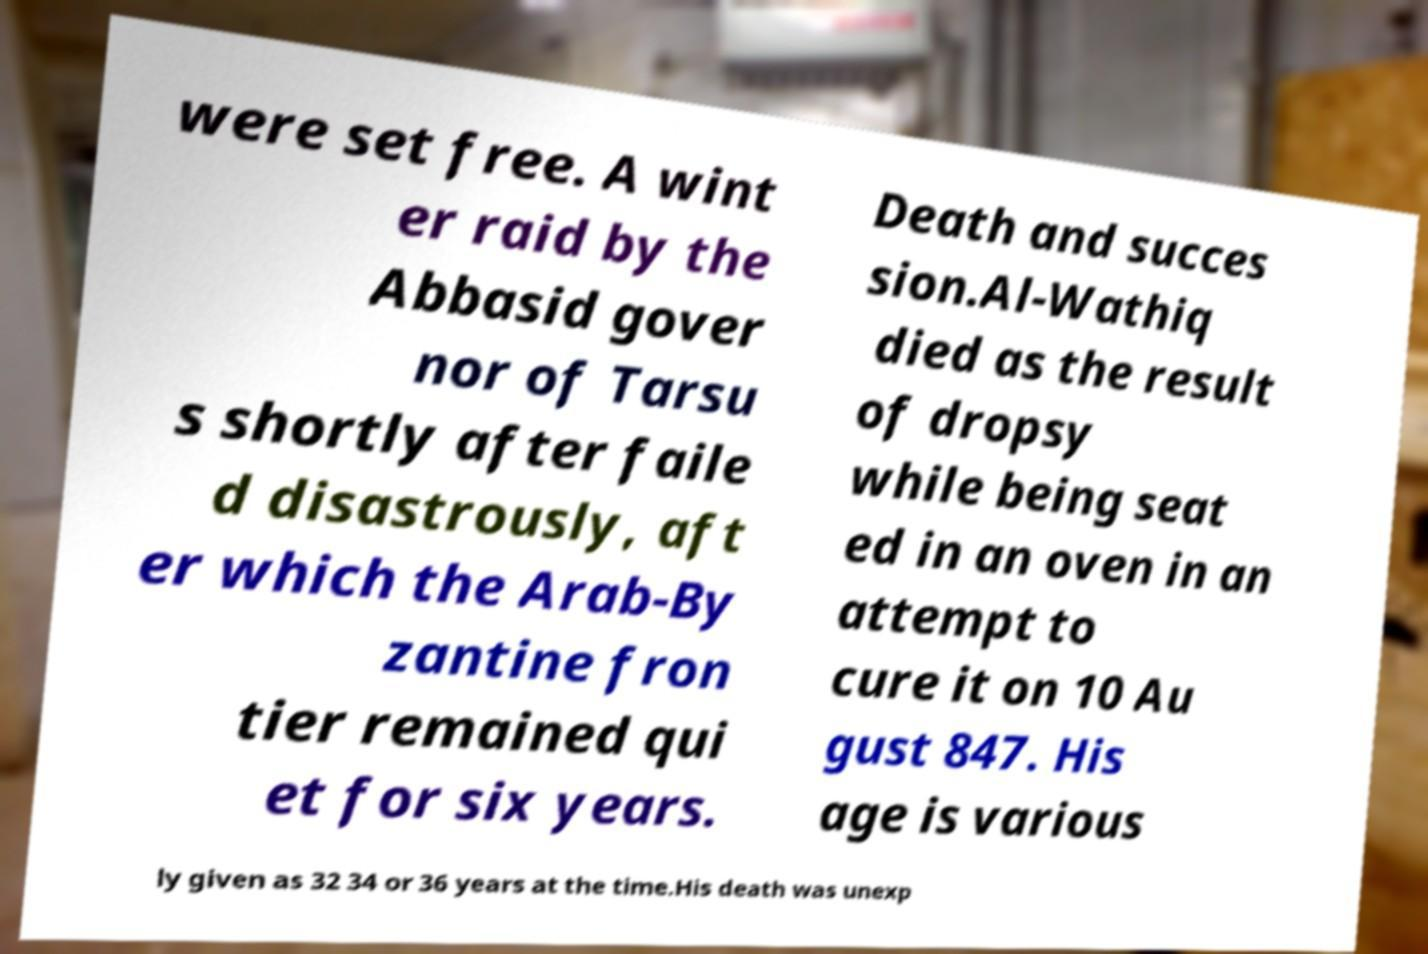Please identify and transcribe the text found in this image. were set free. A wint er raid by the Abbasid gover nor of Tarsu s shortly after faile d disastrously, aft er which the Arab-By zantine fron tier remained qui et for six years. Death and succes sion.Al-Wathiq died as the result of dropsy while being seat ed in an oven in an attempt to cure it on 10 Au gust 847. His age is various ly given as 32 34 or 36 years at the time.His death was unexp 